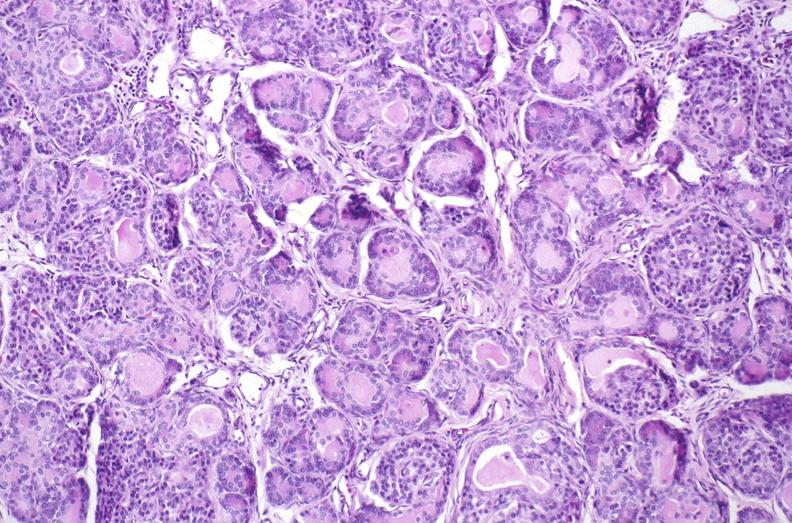s pancreas present?
Answer the question using a single word or phrase. Yes 